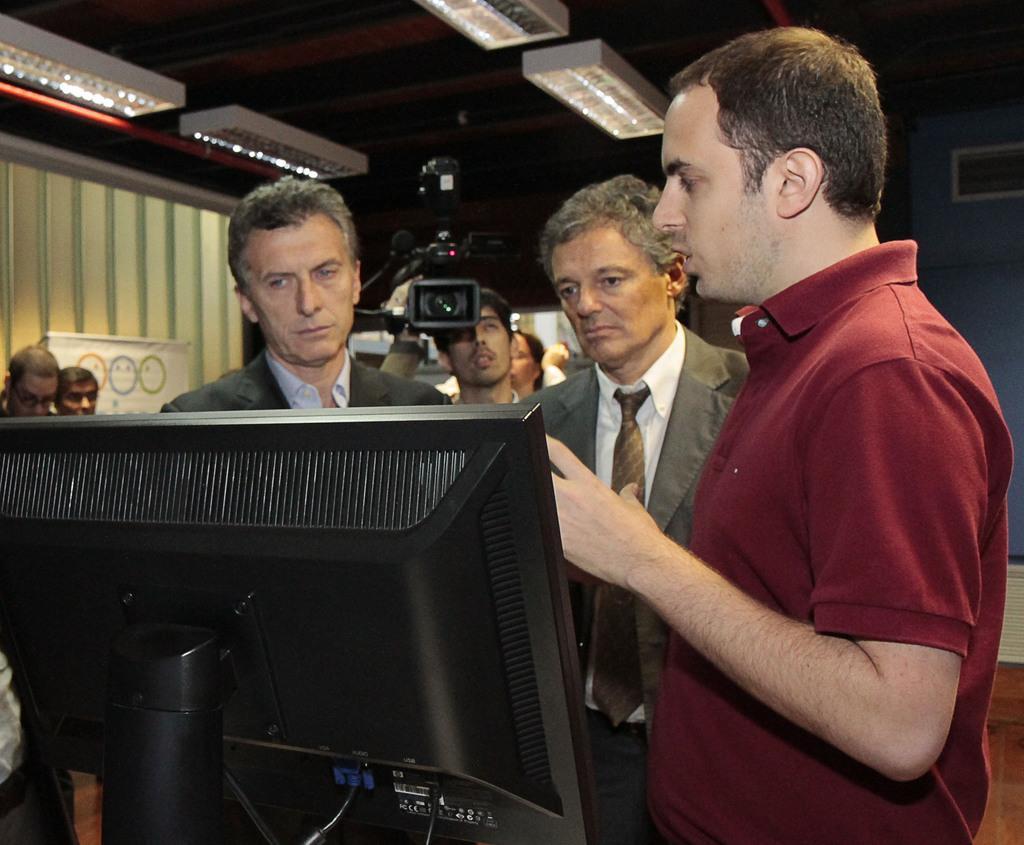Describe this image in one or two sentences. In this image there are group of persons standing. In the front there is a monitor which is black in colour. In the center there is a person holding a camera. In the background there is a white board, there is a curtain and on the top there are lights. 